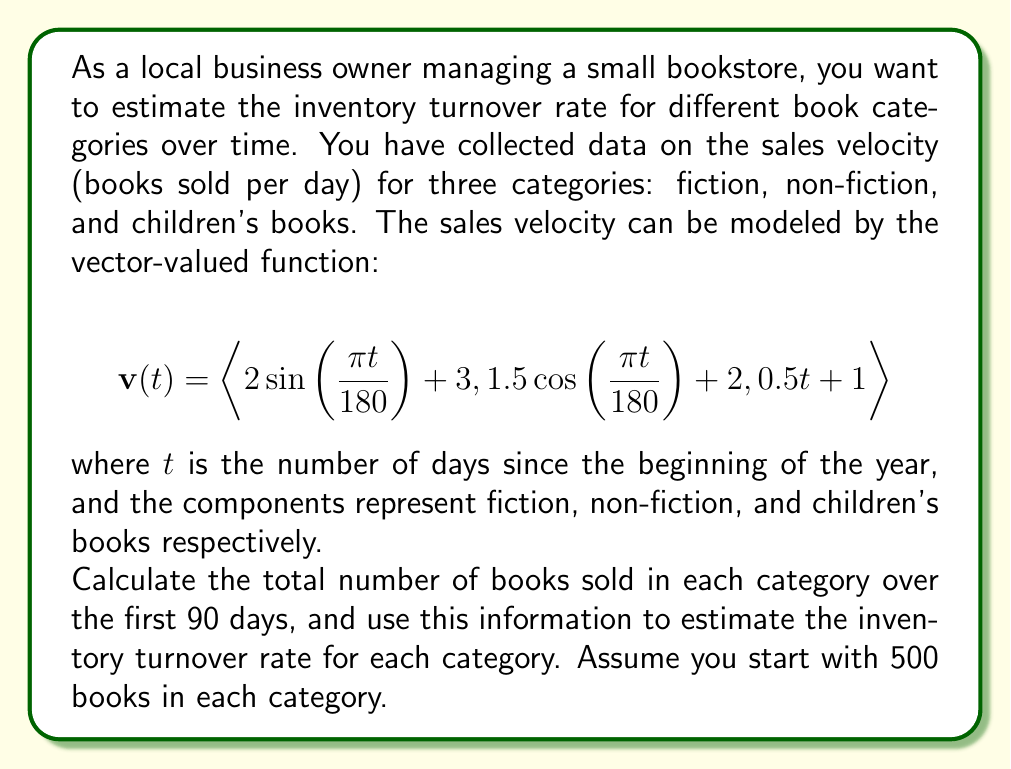Give your solution to this math problem. To solve this problem, we need to follow these steps:

1) First, we need to find the total number of books sold in each category over the 90-day period. This can be done by integrating the vector-valued function from $t=0$ to $t=90$.

2) The integral of a vector-valued function is given by:

   $$\int_a^b \mathbf{v}(t) dt = \langle \int_a^b v_1(t) dt, \int_a^b v_2(t) dt, \int_a^b v_3(t) dt \rangle$$

3) Let's integrate each component:

   For fiction: 
   $$\int_0^{90} (2\sin(\frac{\pi t}{180}) + 3) dt = [-\frac{360}{\pi}\cos(\frac{\pi t}{180}) + 3t]_0^{90} = 270 - \frac{360}{\pi}(\cos(\frac{\pi}{2}) - 1) \approx 384.6$$

   For non-fiction:
   $$\int_0^{90} (1.5\cos(\frac{\pi t}{180}) + 2) dt = [\frac{270}{\pi}\sin(\frac{\pi t}{180}) + 2t]_0^{90} = 180 + \frac{270}{\pi}\sin(\frac{\pi}{2}) \approx 265.9$$

   For children's books:
   $$\int_0^{90} (0.5t + 1) dt = [\frac{1}{4}t^2 + t]_0^{90} = 2025 + 90 = 2115$$

4) Now we have the total number of books sold in each category over 90 days.

5) The inventory turnover rate is calculated as:
   
   Turnover Rate = (Cost of Goods Sold) / (Average Inventory)

   In this case, we can use the number of books sold as the Cost of Goods Sold, and the average of starting and ending inventory as the Average Inventory.

6) For each category:
   
   Fiction: 
   Ending Inventory = 500 - 384.6 = 115.4
   Average Inventory = (500 + 115.4) / 2 = 307.7
   Turnover Rate = 384.6 / 307.7 = 1.25

   Non-fiction:
   Ending Inventory = 500 - 265.9 = 234.1
   Average Inventory = (500 + 234.1) / 2 = 367.05
   Turnover Rate = 265.9 / 367.05 = 0.72

   Children's books:
   Since more books were sold than we started with, we'll assume restocking occurred.
   Average Inventory = 500
   Turnover Rate = 2115 / 500 = 4.23
Answer: The estimated inventory turnover rates for the 90-day period are:
Fiction: 1.25
Non-fiction: 0.72
Children's books: 4.23 